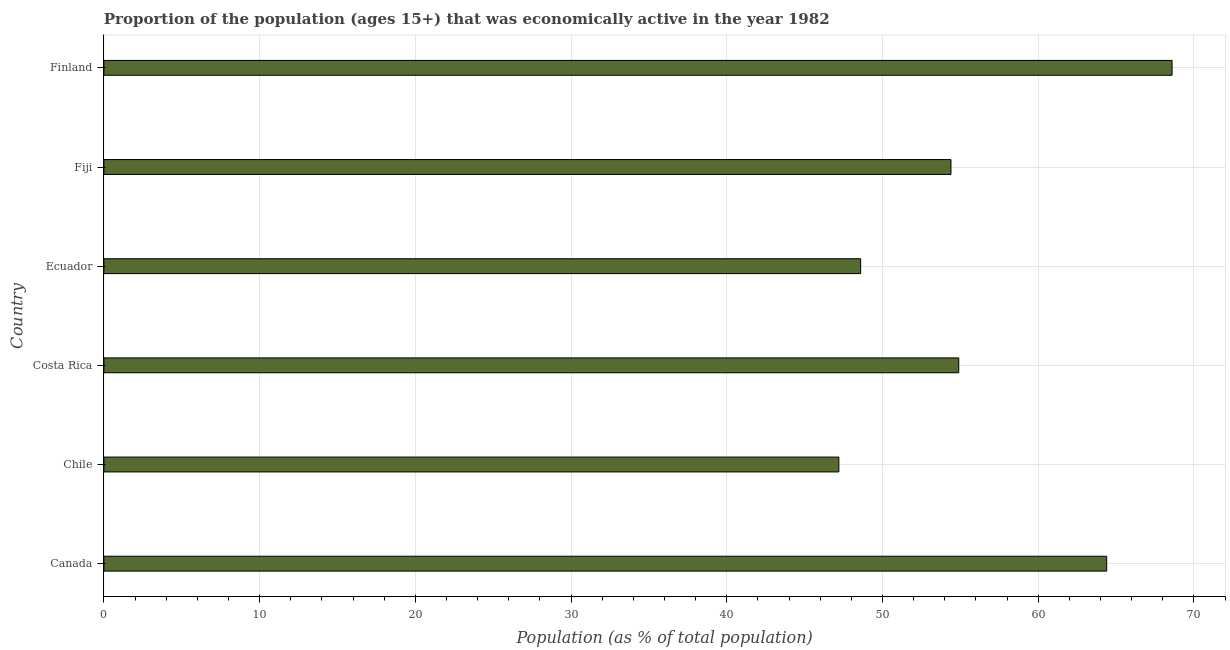Does the graph contain any zero values?
Offer a terse response. No. What is the title of the graph?
Your answer should be compact. Proportion of the population (ages 15+) that was economically active in the year 1982. What is the label or title of the X-axis?
Provide a short and direct response. Population (as % of total population). What is the percentage of economically active population in Costa Rica?
Make the answer very short. 54.9. Across all countries, what is the maximum percentage of economically active population?
Make the answer very short. 68.6. Across all countries, what is the minimum percentage of economically active population?
Your answer should be very brief. 47.2. In which country was the percentage of economically active population maximum?
Give a very brief answer. Finland. What is the sum of the percentage of economically active population?
Keep it short and to the point. 338.1. What is the average percentage of economically active population per country?
Give a very brief answer. 56.35. What is the median percentage of economically active population?
Offer a terse response. 54.65. In how many countries, is the percentage of economically active population greater than 14 %?
Your answer should be very brief. 6. What is the ratio of the percentage of economically active population in Costa Rica to that in Fiji?
Give a very brief answer. 1.01. Is the difference between the percentage of economically active population in Ecuador and Fiji greater than the difference between any two countries?
Ensure brevity in your answer.  No. Is the sum of the percentage of economically active population in Ecuador and Finland greater than the maximum percentage of economically active population across all countries?
Your answer should be very brief. Yes. What is the difference between the highest and the lowest percentage of economically active population?
Your response must be concise. 21.4. How many bars are there?
Your answer should be compact. 6. How many countries are there in the graph?
Keep it short and to the point. 6. What is the Population (as % of total population) of Canada?
Keep it short and to the point. 64.4. What is the Population (as % of total population) of Chile?
Offer a terse response. 47.2. What is the Population (as % of total population) of Costa Rica?
Keep it short and to the point. 54.9. What is the Population (as % of total population) of Ecuador?
Provide a short and direct response. 48.6. What is the Population (as % of total population) in Fiji?
Provide a succinct answer. 54.4. What is the Population (as % of total population) in Finland?
Offer a very short reply. 68.6. What is the difference between the Population (as % of total population) in Canada and Chile?
Offer a very short reply. 17.2. What is the difference between the Population (as % of total population) in Canada and Ecuador?
Offer a terse response. 15.8. What is the difference between the Population (as % of total population) in Canada and Fiji?
Keep it short and to the point. 10. What is the difference between the Population (as % of total population) in Chile and Costa Rica?
Your answer should be very brief. -7.7. What is the difference between the Population (as % of total population) in Chile and Fiji?
Provide a succinct answer. -7.2. What is the difference between the Population (as % of total population) in Chile and Finland?
Offer a very short reply. -21.4. What is the difference between the Population (as % of total population) in Costa Rica and Ecuador?
Ensure brevity in your answer.  6.3. What is the difference between the Population (as % of total population) in Costa Rica and Finland?
Keep it short and to the point. -13.7. What is the difference between the Population (as % of total population) in Ecuador and Fiji?
Your answer should be compact. -5.8. What is the ratio of the Population (as % of total population) in Canada to that in Chile?
Make the answer very short. 1.36. What is the ratio of the Population (as % of total population) in Canada to that in Costa Rica?
Keep it short and to the point. 1.17. What is the ratio of the Population (as % of total population) in Canada to that in Ecuador?
Offer a terse response. 1.32. What is the ratio of the Population (as % of total population) in Canada to that in Fiji?
Provide a succinct answer. 1.18. What is the ratio of the Population (as % of total population) in Canada to that in Finland?
Keep it short and to the point. 0.94. What is the ratio of the Population (as % of total population) in Chile to that in Costa Rica?
Give a very brief answer. 0.86. What is the ratio of the Population (as % of total population) in Chile to that in Fiji?
Give a very brief answer. 0.87. What is the ratio of the Population (as % of total population) in Chile to that in Finland?
Keep it short and to the point. 0.69. What is the ratio of the Population (as % of total population) in Costa Rica to that in Ecuador?
Your answer should be compact. 1.13. What is the ratio of the Population (as % of total population) in Costa Rica to that in Fiji?
Your answer should be compact. 1.01. What is the ratio of the Population (as % of total population) in Ecuador to that in Fiji?
Offer a terse response. 0.89. What is the ratio of the Population (as % of total population) in Ecuador to that in Finland?
Give a very brief answer. 0.71. What is the ratio of the Population (as % of total population) in Fiji to that in Finland?
Offer a very short reply. 0.79. 